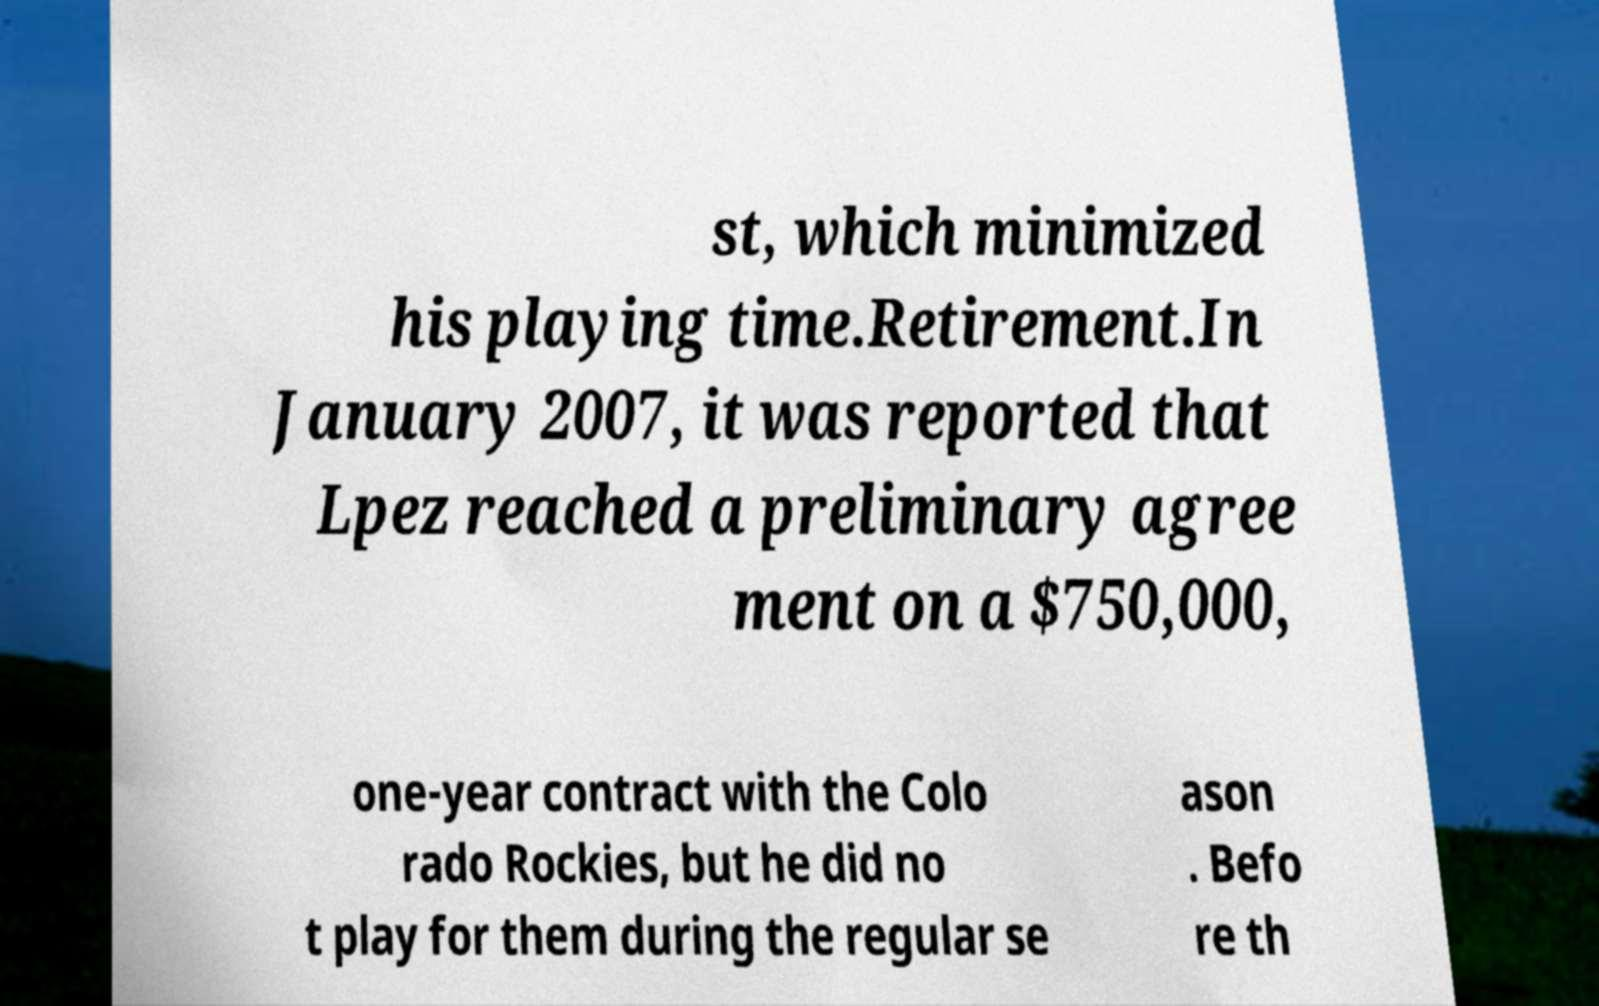Could you assist in decoding the text presented in this image and type it out clearly? st, which minimized his playing time.Retirement.In January 2007, it was reported that Lpez reached a preliminary agree ment on a $750,000, one-year contract with the Colo rado Rockies, but he did no t play for them during the regular se ason . Befo re th 